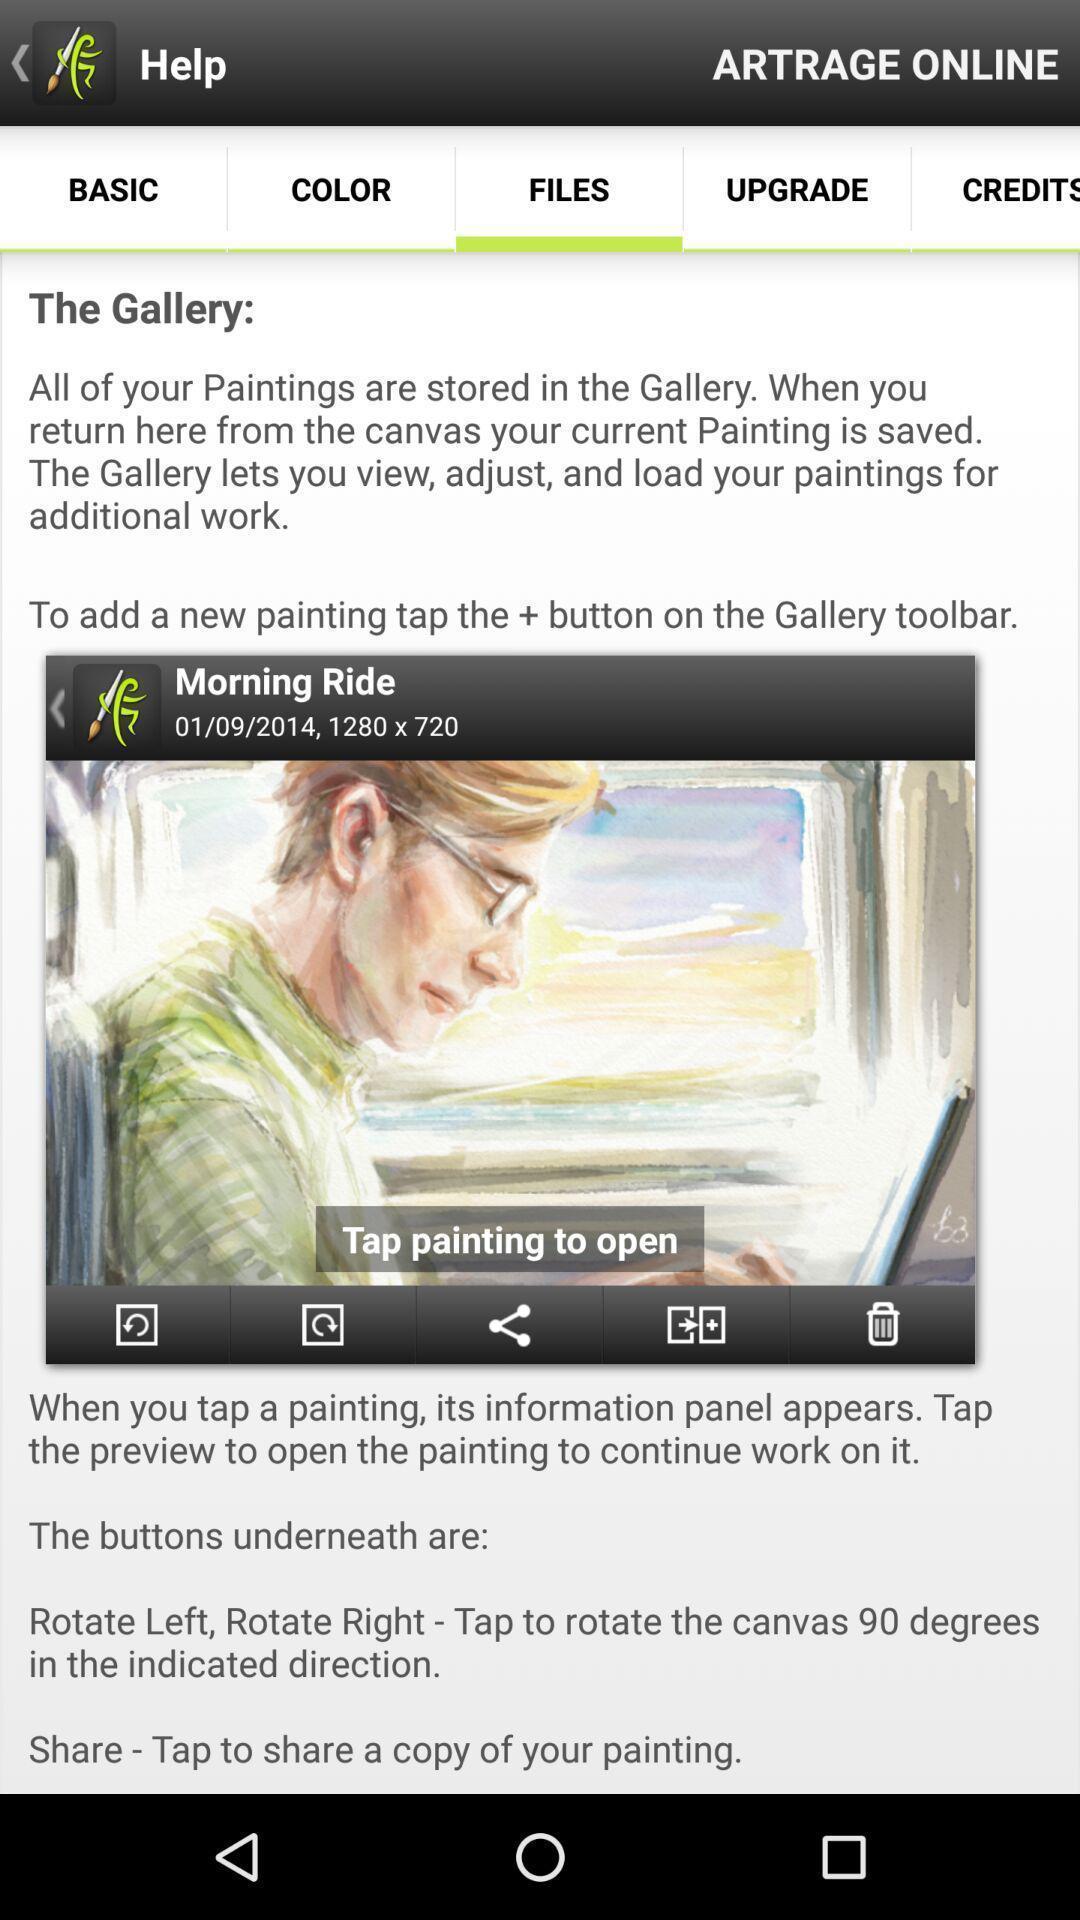Please provide a description for this image. Video with description is displaying under files. 